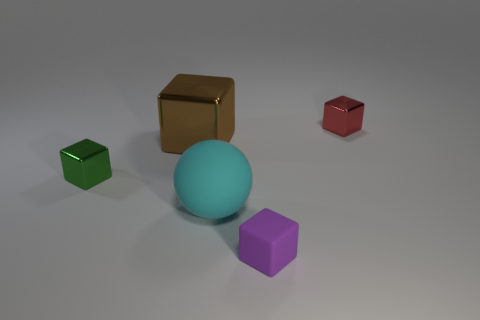Subtract 2 cubes. How many cubes are left? 2 Add 5 large blocks. How many objects exist? 10 Subtract all balls. How many objects are left? 4 Add 4 tiny purple blocks. How many tiny purple blocks are left? 5 Add 3 red shiny objects. How many red shiny objects exist? 4 Subtract 0 brown cylinders. How many objects are left? 5 Subtract all small rubber objects. Subtract all tiny purple balls. How many objects are left? 4 